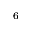<formula> <loc_0><loc_0><loc_500><loc_500>^ { 6 }</formula> 